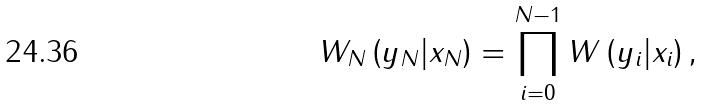Convert formula to latex. <formula><loc_0><loc_0><loc_500><loc_500>W _ { N } \left ( y _ { N } | x _ { N } \right ) = \prod _ { i = 0 } ^ { N - 1 } W \left ( y _ { i } | x _ { i } \right ) ,</formula> 